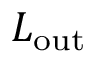Convert formula to latex. <formula><loc_0><loc_0><loc_500><loc_500>L _ { o u t }</formula> 